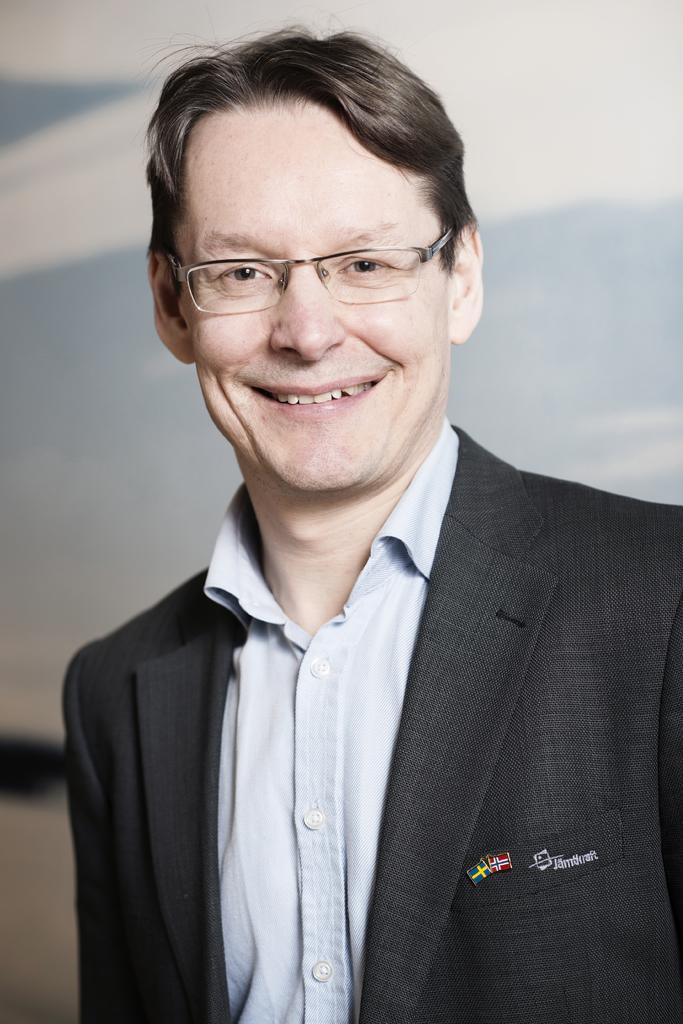Who is present in the image? There is a man in the image. What is the man doing in the image? The man is smiling in the image. What can be seen on the man's face? The man is wearing glasses in the image. What is the man wearing on his upper body? The man is wearing a coat with text and a logo on it. What is visible in the background of the image? There is a wall in the background of the image. What type of milk is being used for the man's treatment in the image? There is: There is no mention of milk or treatment in the image; the man is simply smiling and wearing glasses while wearing a coat with text and a logo. 